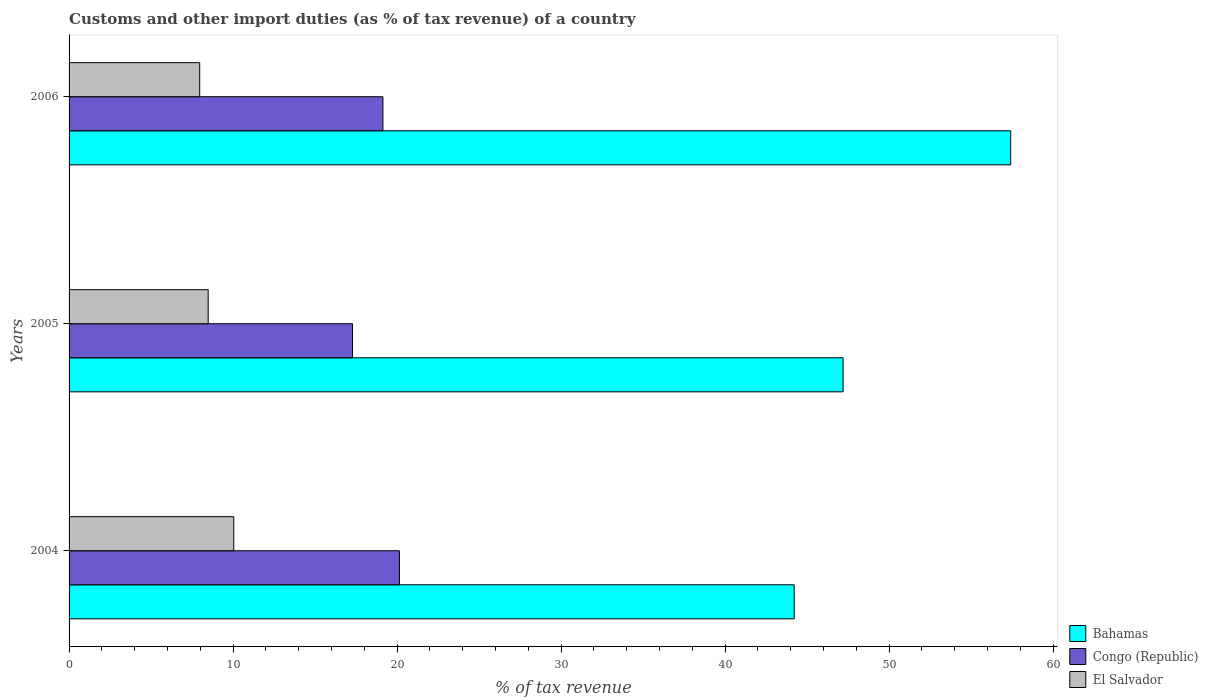How many different coloured bars are there?
Give a very brief answer. 3. How many groups of bars are there?
Ensure brevity in your answer.  3. Are the number of bars per tick equal to the number of legend labels?
Give a very brief answer. Yes. Are the number of bars on each tick of the Y-axis equal?
Make the answer very short. Yes. How many bars are there on the 2nd tick from the top?
Offer a terse response. 3. What is the label of the 2nd group of bars from the top?
Give a very brief answer. 2005. What is the percentage of tax revenue from customs in El Salvador in 2005?
Your answer should be compact. 8.48. Across all years, what is the maximum percentage of tax revenue from customs in Bahamas?
Provide a succinct answer. 57.42. Across all years, what is the minimum percentage of tax revenue from customs in Bahamas?
Provide a short and direct response. 44.21. In which year was the percentage of tax revenue from customs in Bahamas maximum?
Keep it short and to the point. 2006. What is the total percentage of tax revenue from customs in El Salvador in the graph?
Keep it short and to the point. 26.49. What is the difference between the percentage of tax revenue from customs in Bahamas in 2004 and that in 2006?
Offer a very short reply. -13.2. What is the difference between the percentage of tax revenue from customs in Congo (Republic) in 2004 and the percentage of tax revenue from customs in Bahamas in 2006?
Your response must be concise. -37.27. What is the average percentage of tax revenue from customs in Congo (Republic) per year?
Ensure brevity in your answer.  18.85. In the year 2004, what is the difference between the percentage of tax revenue from customs in Congo (Republic) and percentage of tax revenue from customs in El Salvador?
Your answer should be very brief. 10.1. What is the ratio of the percentage of tax revenue from customs in Bahamas in 2005 to that in 2006?
Ensure brevity in your answer.  0.82. Is the difference between the percentage of tax revenue from customs in Congo (Republic) in 2004 and 2006 greater than the difference between the percentage of tax revenue from customs in El Salvador in 2004 and 2006?
Provide a short and direct response. No. What is the difference between the highest and the second highest percentage of tax revenue from customs in Congo (Republic)?
Give a very brief answer. 1.01. What is the difference between the highest and the lowest percentage of tax revenue from customs in Congo (Republic)?
Keep it short and to the point. 2.86. What does the 3rd bar from the top in 2005 represents?
Keep it short and to the point. Bahamas. What does the 2nd bar from the bottom in 2006 represents?
Keep it short and to the point. Congo (Republic). Is it the case that in every year, the sum of the percentage of tax revenue from customs in El Salvador and percentage of tax revenue from customs in Bahamas is greater than the percentage of tax revenue from customs in Congo (Republic)?
Keep it short and to the point. Yes. How many bars are there?
Provide a short and direct response. 9. Are all the bars in the graph horizontal?
Your response must be concise. Yes. How many years are there in the graph?
Give a very brief answer. 3. What is the difference between two consecutive major ticks on the X-axis?
Offer a very short reply. 10. Does the graph contain grids?
Your answer should be very brief. No. What is the title of the graph?
Your answer should be compact. Customs and other import duties (as % of tax revenue) of a country. What is the label or title of the X-axis?
Your response must be concise. % of tax revenue. What is the label or title of the Y-axis?
Give a very brief answer. Years. What is the % of tax revenue of Bahamas in 2004?
Give a very brief answer. 44.21. What is the % of tax revenue in Congo (Republic) in 2004?
Make the answer very short. 20.14. What is the % of tax revenue in El Salvador in 2004?
Make the answer very short. 10.04. What is the % of tax revenue of Bahamas in 2005?
Give a very brief answer. 47.2. What is the % of tax revenue of Congo (Republic) in 2005?
Provide a succinct answer. 17.28. What is the % of tax revenue of El Salvador in 2005?
Ensure brevity in your answer.  8.48. What is the % of tax revenue in Bahamas in 2006?
Offer a very short reply. 57.42. What is the % of tax revenue in Congo (Republic) in 2006?
Keep it short and to the point. 19.14. What is the % of tax revenue of El Salvador in 2006?
Ensure brevity in your answer.  7.97. Across all years, what is the maximum % of tax revenue in Bahamas?
Provide a short and direct response. 57.42. Across all years, what is the maximum % of tax revenue of Congo (Republic)?
Ensure brevity in your answer.  20.14. Across all years, what is the maximum % of tax revenue in El Salvador?
Your response must be concise. 10.04. Across all years, what is the minimum % of tax revenue of Bahamas?
Provide a succinct answer. 44.21. Across all years, what is the minimum % of tax revenue in Congo (Republic)?
Your response must be concise. 17.28. Across all years, what is the minimum % of tax revenue in El Salvador?
Give a very brief answer. 7.97. What is the total % of tax revenue of Bahamas in the graph?
Offer a terse response. 148.83. What is the total % of tax revenue in Congo (Republic) in the graph?
Ensure brevity in your answer.  56.56. What is the total % of tax revenue of El Salvador in the graph?
Your answer should be compact. 26.49. What is the difference between the % of tax revenue of Bahamas in 2004 and that in 2005?
Provide a succinct answer. -2.98. What is the difference between the % of tax revenue in Congo (Republic) in 2004 and that in 2005?
Your answer should be compact. 2.86. What is the difference between the % of tax revenue of El Salvador in 2004 and that in 2005?
Keep it short and to the point. 1.56. What is the difference between the % of tax revenue in Bahamas in 2004 and that in 2006?
Your response must be concise. -13.2. What is the difference between the % of tax revenue of Congo (Republic) in 2004 and that in 2006?
Provide a succinct answer. 1.01. What is the difference between the % of tax revenue of El Salvador in 2004 and that in 2006?
Your answer should be compact. 2.08. What is the difference between the % of tax revenue of Bahamas in 2005 and that in 2006?
Keep it short and to the point. -10.22. What is the difference between the % of tax revenue in Congo (Republic) in 2005 and that in 2006?
Provide a short and direct response. -1.85. What is the difference between the % of tax revenue of El Salvador in 2005 and that in 2006?
Give a very brief answer. 0.52. What is the difference between the % of tax revenue in Bahamas in 2004 and the % of tax revenue in Congo (Republic) in 2005?
Give a very brief answer. 26.93. What is the difference between the % of tax revenue of Bahamas in 2004 and the % of tax revenue of El Salvador in 2005?
Ensure brevity in your answer.  35.73. What is the difference between the % of tax revenue in Congo (Republic) in 2004 and the % of tax revenue in El Salvador in 2005?
Give a very brief answer. 11.66. What is the difference between the % of tax revenue of Bahamas in 2004 and the % of tax revenue of Congo (Republic) in 2006?
Your response must be concise. 25.08. What is the difference between the % of tax revenue of Bahamas in 2004 and the % of tax revenue of El Salvador in 2006?
Your response must be concise. 36.25. What is the difference between the % of tax revenue of Congo (Republic) in 2004 and the % of tax revenue of El Salvador in 2006?
Provide a succinct answer. 12.18. What is the difference between the % of tax revenue of Bahamas in 2005 and the % of tax revenue of Congo (Republic) in 2006?
Provide a short and direct response. 28.06. What is the difference between the % of tax revenue in Bahamas in 2005 and the % of tax revenue in El Salvador in 2006?
Give a very brief answer. 39.23. What is the difference between the % of tax revenue in Congo (Republic) in 2005 and the % of tax revenue in El Salvador in 2006?
Provide a succinct answer. 9.32. What is the average % of tax revenue of Bahamas per year?
Give a very brief answer. 49.61. What is the average % of tax revenue in Congo (Republic) per year?
Provide a succinct answer. 18.85. What is the average % of tax revenue of El Salvador per year?
Your answer should be compact. 8.83. In the year 2004, what is the difference between the % of tax revenue of Bahamas and % of tax revenue of Congo (Republic)?
Your response must be concise. 24.07. In the year 2004, what is the difference between the % of tax revenue in Bahamas and % of tax revenue in El Salvador?
Offer a very short reply. 34.17. In the year 2004, what is the difference between the % of tax revenue in Congo (Republic) and % of tax revenue in El Salvador?
Offer a terse response. 10.1. In the year 2005, what is the difference between the % of tax revenue of Bahamas and % of tax revenue of Congo (Republic)?
Ensure brevity in your answer.  29.91. In the year 2005, what is the difference between the % of tax revenue of Bahamas and % of tax revenue of El Salvador?
Provide a succinct answer. 38.72. In the year 2005, what is the difference between the % of tax revenue in Congo (Republic) and % of tax revenue in El Salvador?
Provide a short and direct response. 8.8. In the year 2006, what is the difference between the % of tax revenue in Bahamas and % of tax revenue in Congo (Republic)?
Keep it short and to the point. 38.28. In the year 2006, what is the difference between the % of tax revenue in Bahamas and % of tax revenue in El Salvador?
Your answer should be very brief. 49.45. In the year 2006, what is the difference between the % of tax revenue of Congo (Republic) and % of tax revenue of El Salvador?
Make the answer very short. 11.17. What is the ratio of the % of tax revenue in Bahamas in 2004 to that in 2005?
Provide a short and direct response. 0.94. What is the ratio of the % of tax revenue of Congo (Republic) in 2004 to that in 2005?
Offer a very short reply. 1.17. What is the ratio of the % of tax revenue of El Salvador in 2004 to that in 2005?
Make the answer very short. 1.18. What is the ratio of the % of tax revenue of Bahamas in 2004 to that in 2006?
Provide a short and direct response. 0.77. What is the ratio of the % of tax revenue in Congo (Republic) in 2004 to that in 2006?
Give a very brief answer. 1.05. What is the ratio of the % of tax revenue in El Salvador in 2004 to that in 2006?
Your answer should be compact. 1.26. What is the ratio of the % of tax revenue of Bahamas in 2005 to that in 2006?
Provide a succinct answer. 0.82. What is the ratio of the % of tax revenue in Congo (Republic) in 2005 to that in 2006?
Your answer should be compact. 0.9. What is the ratio of the % of tax revenue in El Salvador in 2005 to that in 2006?
Give a very brief answer. 1.06. What is the difference between the highest and the second highest % of tax revenue in Bahamas?
Your answer should be compact. 10.22. What is the difference between the highest and the second highest % of tax revenue of El Salvador?
Offer a terse response. 1.56. What is the difference between the highest and the lowest % of tax revenue of Bahamas?
Keep it short and to the point. 13.2. What is the difference between the highest and the lowest % of tax revenue in Congo (Republic)?
Offer a very short reply. 2.86. What is the difference between the highest and the lowest % of tax revenue in El Salvador?
Your answer should be compact. 2.08. 